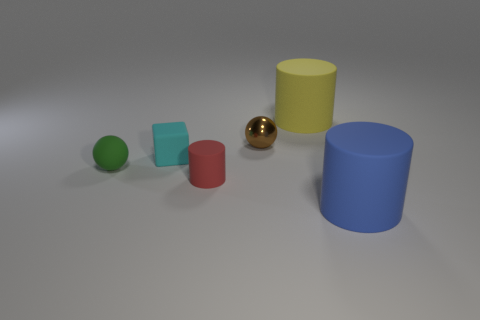Add 1 large blue metal things. How many objects exist? 7 Subtract all spheres. How many objects are left? 4 Subtract all small brown matte cubes. Subtract all red cylinders. How many objects are left? 5 Add 2 tiny red things. How many tiny red things are left? 3 Add 6 tiny green matte objects. How many tiny green matte objects exist? 7 Subtract 0 gray balls. How many objects are left? 6 